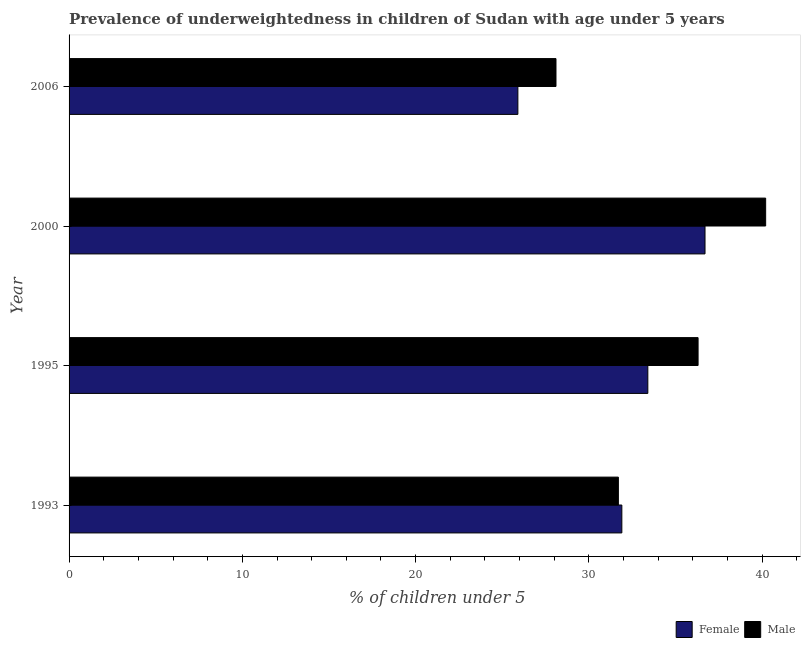How many different coloured bars are there?
Your response must be concise. 2. How many bars are there on the 4th tick from the top?
Ensure brevity in your answer.  2. What is the label of the 4th group of bars from the top?
Make the answer very short. 1993. What is the percentage of underweighted male children in 1995?
Your answer should be compact. 36.3. Across all years, what is the maximum percentage of underweighted female children?
Offer a terse response. 36.7. Across all years, what is the minimum percentage of underweighted female children?
Give a very brief answer. 25.9. In which year was the percentage of underweighted female children minimum?
Provide a succinct answer. 2006. What is the total percentage of underweighted female children in the graph?
Give a very brief answer. 127.9. What is the difference between the percentage of underweighted male children in 1993 and that in 2006?
Make the answer very short. 3.6. What is the difference between the percentage of underweighted male children in 2006 and the percentage of underweighted female children in 1993?
Provide a succinct answer. -3.8. What is the average percentage of underweighted female children per year?
Ensure brevity in your answer.  31.98. What is the ratio of the percentage of underweighted female children in 1993 to that in 2006?
Offer a terse response. 1.23. Is the percentage of underweighted male children in 1995 less than that in 2000?
Keep it short and to the point. Yes. What is the difference between the highest and the second highest percentage of underweighted male children?
Provide a short and direct response. 3.9. What is the difference between the highest and the lowest percentage of underweighted female children?
Keep it short and to the point. 10.8. Is the sum of the percentage of underweighted male children in 1993 and 2000 greater than the maximum percentage of underweighted female children across all years?
Offer a very short reply. Yes. What does the 1st bar from the bottom in 2000 represents?
Ensure brevity in your answer.  Female. Are all the bars in the graph horizontal?
Your response must be concise. Yes. How many years are there in the graph?
Give a very brief answer. 4. What is the difference between two consecutive major ticks on the X-axis?
Provide a succinct answer. 10. Are the values on the major ticks of X-axis written in scientific E-notation?
Make the answer very short. No. Does the graph contain grids?
Your answer should be very brief. No. Where does the legend appear in the graph?
Provide a short and direct response. Bottom right. How many legend labels are there?
Your answer should be compact. 2. What is the title of the graph?
Your response must be concise. Prevalence of underweightedness in children of Sudan with age under 5 years. What is the label or title of the X-axis?
Offer a very short reply.  % of children under 5. What is the label or title of the Y-axis?
Provide a short and direct response. Year. What is the  % of children under 5 in Female in 1993?
Offer a very short reply. 31.9. What is the  % of children under 5 of Male in 1993?
Provide a short and direct response. 31.7. What is the  % of children under 5 of Female in 1995?
Give a very brief answer. 33.4. What is the  % of children under 5 of Male in 1995?
Give a very brief answer. 36.3. What is the  % of children under 5 in Female in 2000?
Keep it short and to the point. 36.7. What is the  % of children under 5 of Male in 2000?
Provide a succinct answer. 40.2. What is the  % of children under 5 in Female in 2006?
Provide a short and direct response. 25.9. What is the  % of children under 5 of Male in 2006?
Ensure brevity in your answer.  28.1. Across all years, what is the maximum  % of children under 5 in Female?
Make the answer very short. 36.7. Across all years, what is the maximum  % of children under 5 in Male?
Your answer should be compact. 40.2. Across all years, what is the minimum  % of children under 5 of Female?
Your response must be concise. 25.9. Across all years, what is the minimum  % of children under 5 of Male?
Your response must be concise. 28.1. What is the total  % of children under 5 in Female in the graph?
Keep it short and to the point. 127.9. What is the total  % of children under 5 of Male in the graph?
Your response must be concise. 136.3. What is the difference between the  % of children under 5 in Male in 1993 and that in 1995?
Provide a succinct answer. -4.6. What is the difference between the  % of children under 5 in Female in 1993 and that in 2006?
Offer a very short reply. 6. What is the difference between the  % of children under 5 in Male in 1993 and that in 2006?
Provide a succinct answer. 3.6. What is the difference between the  % of children under 5 of Male in 1995 and that in 2000?
Your response must be concise. -3.9. What is the difference between the  % of children under 5 in Male in 1995 and that in 2006?
Offer a terse response. 8.2. What is the difference between the  % of children under 5 in Female in 2000 and that in 2006?
Provide a succinct answer. 10.8. What is the difference between the  % of children under 5 in Female in 1993 and the  % of children under 5 in Male in 1995?
Give a very brief answer. -4.4. What is the difference between the  % of children under 5 of Female in 1995 and the  % of children under 5 of Male in 2000?
Provide a succinct answer. -6.8. What is the difference between the  % of children under 5 of Female in 1995 and the  % of children under 5 of Male in 2006?
Offer a terse response. 5.3. What is the difference between the  % of children under 5 of Female in 2000 and the  % of children under 5 of Male in 2006?
Give a very brief answer. 8.6. What is the average  % of children under 5 in Female per year?
Offer a terse response. 31.98. What is the average  % of children under 5 in Male per year?
Your answer should be very brief. 34.08. In the year 1993, what is the difference between the  % of children under 5 in Female and  % of children under 5 in Male?
Your answer should be very brief. 0.2. In the year 2006, what is the difference between the  % of children under 5 in Female and  % of children under 5 in Male?
Make the answer very short. -2.2. What is the ratio of the  % of children under 5 of Female in 1993 to that in 1995?
Give a very brief answer. 0.96. What is the ratio of the  % of children under 5 in Male in 1993 to that in 1995?
Your response must be concise. 0.87. What is the ratio of the  % of children under 5 of Female in 1993 to that in 2000?
Give a very brief answer. 0.87. What is the ratio of the  % of children under 5 of Male in 1993 to that in 2000?
Give a very brief answer. 0.79. What is the ratio of the  % of children under 5 in Female in 1993 to that in 2006?
Provide a succinct answer. 1.23. What is the ratio of the  % of children under 5 of Male in 1993 to that in 2006?
Offer a very short reply. 1.13. What is the ratio of the  % of children under 5 of Female in 1995 to that in 2000?
Offer a terse response. 0.91. What is the ratio of the  % of children under 5 in Male in 1995 to that in 2000?
Your answer should be very brief. 0.9. What is the ratio of the  % of children under 5 in Female in 1995 to that in 2006?
Your response must be concise. 1.29. What is the ratio of the  % of children under 5 of Male in 1995 to that in 2006?
Provide a succinct answer. 1.29. What is the ratio of the  % of children under 5 in Female in 2000 to that in 2006?
Make the answer very short. 1.42. What is the ratio of the  % of children under 5 in Male in 2000 to that in 2006?
Make the answer very short. 1.43. What is the difference between the highest and the lowest  % of children under 5 in Male?
Make the answer very short. 12.1. 